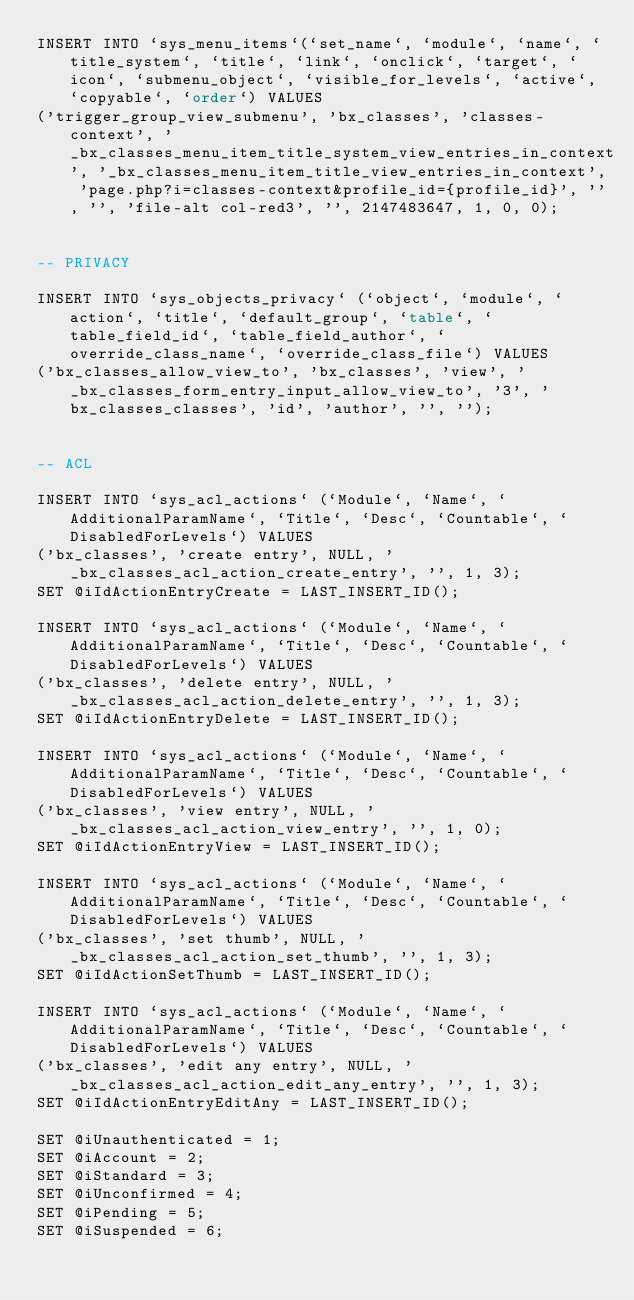Convert code to text. <code><loc_0><loc_0><loc_500><loc_500><_SQL_>INSERT INTO `sys_menu_items`(`set_name`, `module`, `name`, `title_system`, `title`, `link`, `onclick`, `target`, `icon`, `submenu_object`, `visible_for_levels`, `active`, `copyable`, `order`) VALUES
('trigger_group_view_submenu', 'bx_classes', 'classes-context', '_bx_classes_menu_item_title_system_view_entries_in_context', '_bx_classes_menu_item_title_view_entries_in_context', 'page.php?i=classes-context&profile_id={profile_id}', '', '', 'file-alt col-red3', '', 2147483647, 1, 0, 0);


-- PRIVACY 

INSERT INTO `sys_objects_privacy` (`object`, `module`, `action`, `title`, `default_group`, `table`, `table_field_id`, `table_field_author`, `override_class_name`, `override_class_file`) VALUES
('bx_classes_allow_view_to', 'bx_classes', 'view', '_bx_classes_form_entry_input_allow_view_to', '3', 'bx_classes_classes', 'id', 'author', '', '');


-- ACL

INSERT INTO `sys_acl_actions` (`Module`, `Name`, `AdditionalParamName`, `Title`, `Desc`, `Countable`, `DisabledForLevels`) VALUES
('bx_classes', 'create entry', NULL, '_bx_classes_acl_action_create_entry', '', 1, 3);
SET @iIdActionEntryCreate = LAST_INSERT_ID();

INSERT INTO `sys_acl_actions` (`Module`, `Name`, `AdditionalParamName`, `Title`, `Desc`, `Countable`, `DisabledForLevels`) VALUES
('bx_classes', 'delete entry', NULL, '_bx_classes_acl_action_delete_entry', '', 1, 3);
SET @iIdActionEntryDelete = LAST_INSERT_ID();

INSERT INTO `sys_acl_actions` (`Module`, `Name`, `AdditionalParamName`, `Title`, `Desc`, `Countable`, `DisabledForLevels`) VALUES
('bx_classes', 'view entry', NULL, '_bx_classes_acl_action_view_entry', '', 1, 0);
SET @iIdActionEntryView = LAST_INSERT_ID();

INSERT INTO `sys_acl_actions` (`Module`, `Name`, `AdditionalParamName`, `Title`, `Desc`, `Countable`, `DisabledForLevels`) VALUES
('bx_classes', 'set thumb', NULL, '_bx_classes_acl_action_set_thumb', '', 1, 3);
SET @iIdActionSetThumb = LAST_INSERT_ID();

INSERT INTO `sys_acl_actions` (`Module`, `Name`, `AdditionalParamName`, `Title`, `Desc`, `Countable`, `DisabledForLevels`) VALUES
('bx_classes', 'edit any entry', NULL, '_bx_classes_acl_action_edit_any_entry', '', 1, 3);
SET @iIdActionEntryEditAny = LAST_INSERT_ID();

SET @iUnauthenticated = 1;
SET @iAccount = 2;
SET @iStandard = 3;
SET @iUnconfirmed = 4;
SET @iPending = 5;
SET @iSuspended = 6;</code> 